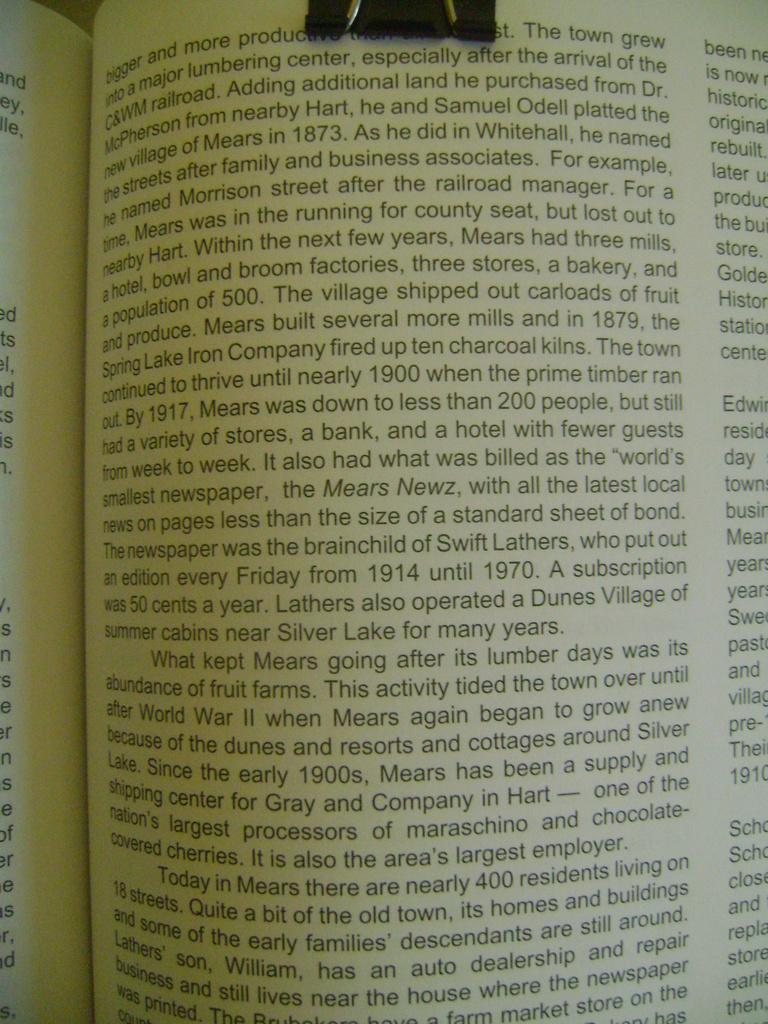<image>
Provide a brief description of the given image. The first words on this page shown are bigger and more. 